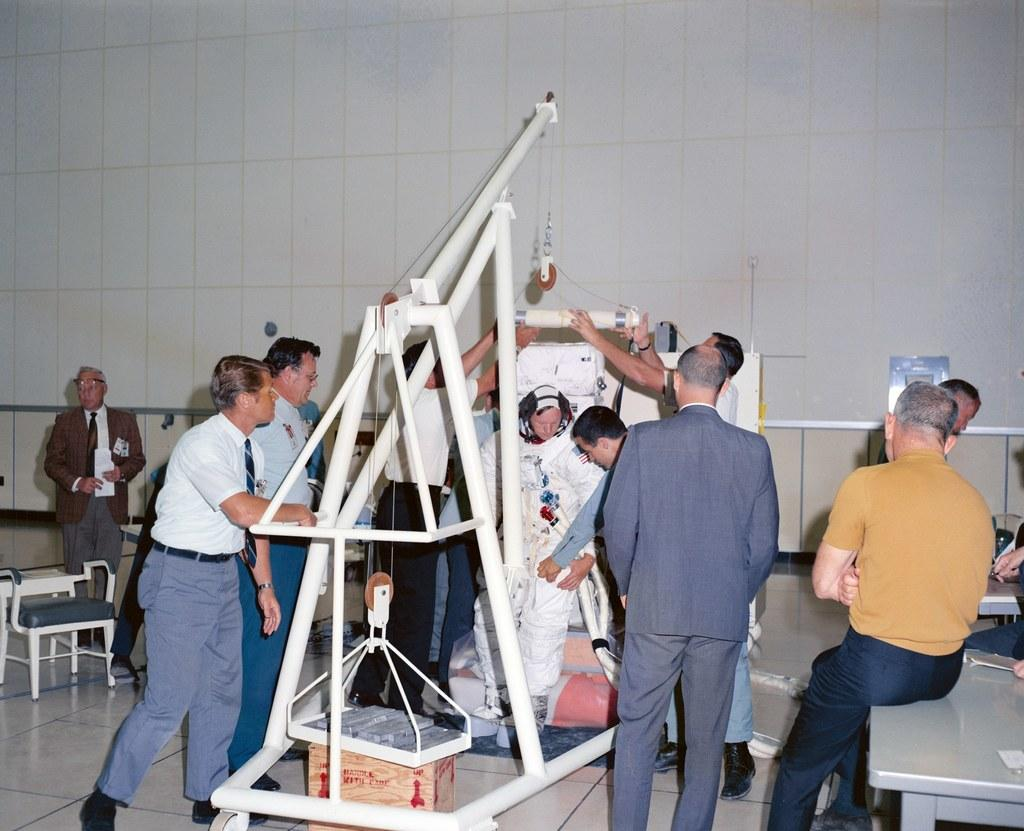How many people are present in the image? There are people in the image, but the exact number cannot be determined from the provided facts. What can be seen besides people in the image? There are rods, a cardboard box, a board, tables, chairs, and objects visible in the image. What is the floor like in the image? The floor is visible in the image, but its appearance cannot be determined from the provided facts. What is the background of the image like? There is a wall in the background of the image. What type of seed is being used in the image? There is no mention of seeds in the provided facts. 